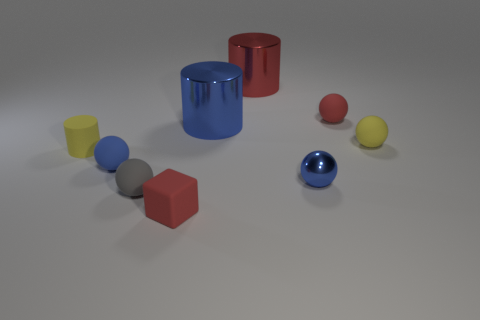Subtract all rubber balls. How many balls are left? 1 Add 1 tiny brown metal cubes. How many objects exist? 10 Subtract all gray cubes. How many blue balls are left? 2 Subtract all yellow spheres. How many spheres are left? 4 Subtract all cylinders. How many objects are left? 6 Subtract 1 cylinders. How many cylinders are left? 2 Subtract all purple spheres. Subtract all red cylinders. How many spheres are left? 5 Subtract all red objects. Subtract all small matte cylinders. How many objects are left? 5 Add 7 small red blocks. How many small red blocks are left? 8 Add 1 tiny things. How many tiny things exist? 8 